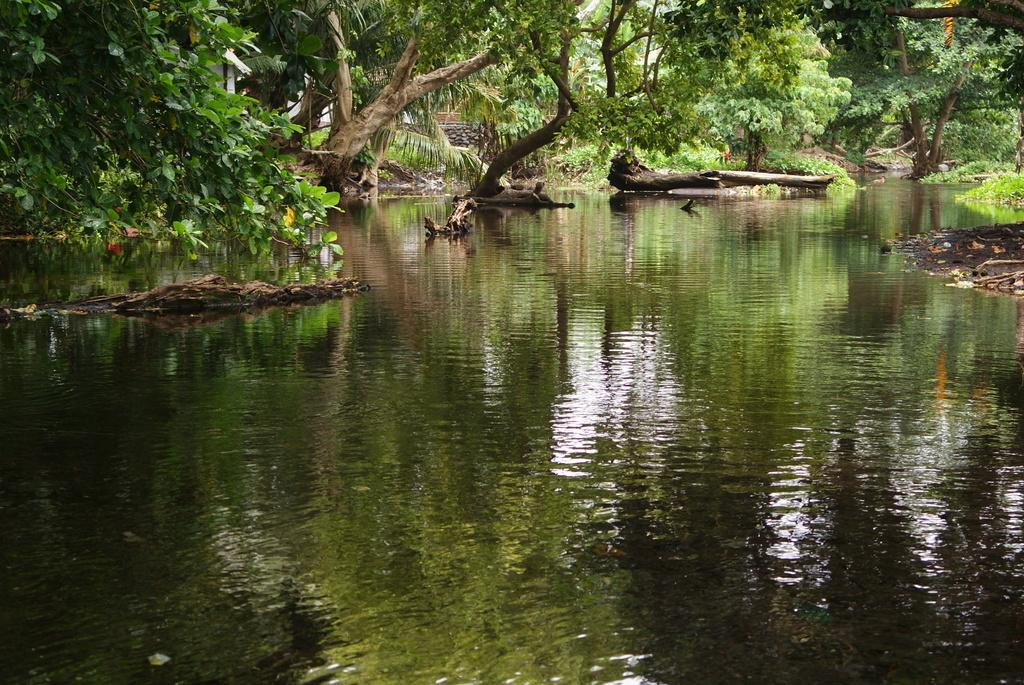What is located at the bottom of the image? There is a lake at the bottom of the image. What can be seen in the background of the image? There are trees in the background of the image. What objects are present in the image? There are logs in the image. What type of pipe can be seen in the image? There is no pipe present in the image. How many houses are visible in the image? There are no houses visible in the image. 